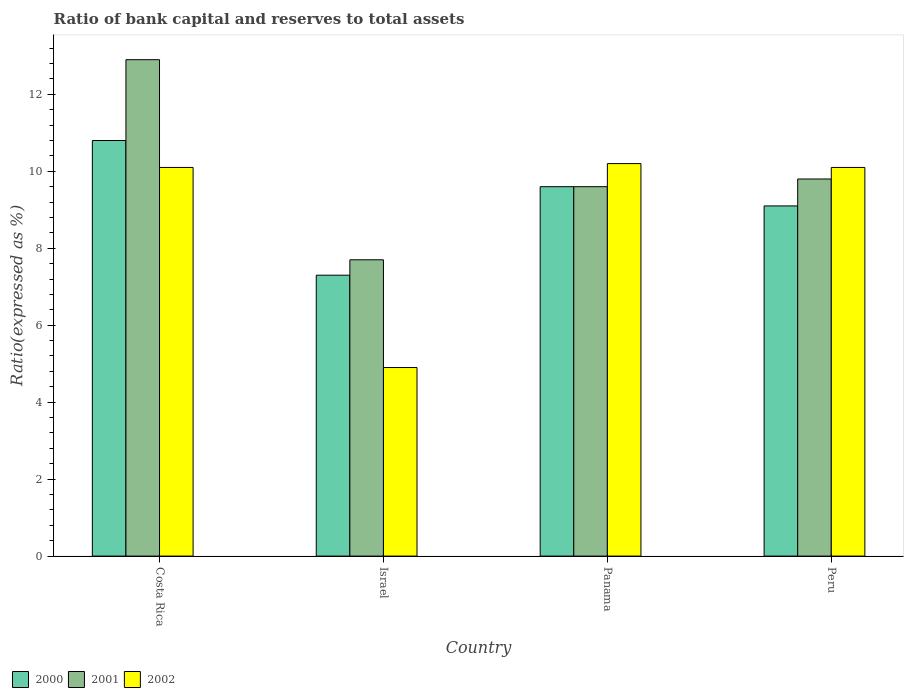What is the label of the 1st group of bars from the left?
Give a very brief answer. Costa Rica. In how many cases, is the number of bars for a given country not equal to the number of legend labels?
Provide a succinct answer. 0. In which country was the ratio of bank capital and reserves to total assets in 2000 minimum?
Provide a short and direct response. Israel. What is the total ratio of bank capital and reserves to total assets in 2000 in the graph?
Your answer should be very brief. 36.8. What is the difference between the ratio of bank capital and reserves to total assets in 2000 in Israel and that in Panama?
Your answer should be very brief. -2.3. What is the difference between the ratio of bank capital and reserves to total assets in 2002 in Peru and the ratio of bank capital and reserves to total assets in 2001 in Panama?
Provide a short and direct response. 0.5. What is the average ratio of bank capital and reserves to total assets in 2000 per country?
Offer a very short reply. 9.2. What is the difference between the ratio of bank capital and reserves to total assets of/in 2002 and ratio of bank capital and reserves to total assets of/in 2001 in Peru?
Keep it short and to the point. 0.3. In how many countries, is the ratio of bank capital and reserves to total assets in 2001 greater than 7.2 %?
Offer a very short reply. 4. What is the ratio of the ratio of bank capital and reserves to total assets in 2000 in Panama to that in Peru?
Provide a succinct answer. 1.05. Is the difference between the ratio of bank capital and reserves to total assets in 2002 in Israel and Panama greater than the difference between the ratio of bank capital and reserves to total assets in 2001 in Israel and Panama?
Keep it short and to the point. No. What is the difference between the highest and the second highest ratio of bank capital and reserves to total assets in 2001?
Give a very brief answer. -3.1. In how many countries, is the ratio of bank capital and reserves to total assets in 2000 greater than the average ratio of bank capital and reserves to total assets in 2000 taken over all countries?
Your answer should be very brief. 2. Is the sum of the ratio of bank capital and reserves to total assets in 2002 in Costa Rica and Israel greater than the maximum ratio of bank capital and reserves to total assets in 2001 across all countries?
Offer a very short reply. Yes. What does the 3rd bar from the left in Costa Rica represents?
Ensure brevity in your answer.  2002. Is it the case that in every country, the sum of the ratio of bank capital and reserves to total assets in 2002 and ratio of bank capital and reserves to total assets in 2000 is greater than the ratio of bank capital and reserves to total assets in 2001?
Make the answer very short. Yes. Are all the bars in the graph horizontal?
Your response must be concise. No. Are the values on the major ticks of Y-axis written in scientific E-notation?
Ensure brevity in your answer.  No. Does the graph contain grids?
Give a very brief answer. No. Where does the legend appear in the graph?
Give a very brief answer. Bottom left. How are the legend labels stacked?
Your response must be concise. Horizontal. What is the title of the graph?
Offer a terse response. Ratio of bank capital and reserves to total assets. Does "1990" appear as one of the legend labels in the graph?
Offer a terse response. No. What is the label or title of the Y-axis?
Provide a short and direct response. Ratio(expressed as %). What is the Ratio(expressed as %) in 2000 in Costa Rica?
Ensure brevity in your answer.  10.8. What is the Ratio(expressed as %) in 2002 in Costa Rica?
Offer a very short reply. 10.1. What is the Ratio(expressed as %) in 2000 in Panama?
Provide a succinct answer. 9.6. What is the Ratio(expressed as %) in 2002 in Panama?
Your response must be concise. 10.2. What is the Ratio(expressed as %) of 2000 in Peru?
Offer a very short reply. 9.1. Across all countries, what is the maximum Ratio(expressed as %) of 2001?
Your answer should be very brief. 12.9. What is the total Ratio(expressed as %) in 2000 in the graph?
Give a very brief answer. 36.8. What is the total Ratio(expressed as %) in 2001 in the graph?
Give a very brief answer. 40. What is the total Ratio(expressed as %) of 2002 in the graph?
Keep it short and to the point. 35.3. What is the difference between the Ratio(expressed as %) in 2000 in Costa Rica and that in Israel?
Your answer should be very brief. 3.5. What is the difference between the Ratio(expressed as %) in 2000 in Costa Rica and that in Panama?
Provide a succinct answer. 1.2. What is the difference between the Ratio(expressed as %) in 2001 in Costa Rica and that in Panama?
Provide a succinct answer. 3.3. What is the difference between the Ratio(expressed as %) in 2001 in Costa Rica and that in Peru?
Your response must be concise. 3.1. What is the difference between the Ratio(expressed as %) in 2002 in Costa Rica and that in Peru?
Your answer should be very brief. 0. What is the difference between the Ratio(expressed as %) in 2000 in Israel and that in Panama?
Make the answer very short. -2.3. What is the difference between the Ratio(expressed as %) in 2001 in Israel and that in Panama?
Your answer should be compact. -1.9. What is the difference between the Ratio(expressed as %) of 2001 in Israel and that in Peru?
Provide a succinct answer. -2.1. What is the difference between the Ratio(expressed as %) in 2002 in Israel and that in Peru?
Your answer should be very brief. -5.2. What is the difference between the Ratio(expressed as %) of 2000 in Panama and that in Peru?
Offer a very short reply. 0.5. What is the difference between the Ratio(expressed as %) of 2000 in Costa Rica and the Ratio(expressed as %) of 2001 in Israel?
Your response must be concise. 3.1. What is the difference between the Ratio(expressed as %) in 2000 in Costa Rica and the Ratio(expressed as %) in 2001 in Panama?
Give a very brief answer. 1.2. What is the difference between the Ratio(expressed as %) of 2000 in Costa Rica and the Ratio(expressed as %) of 2002 in Panama?
Your answer should be very brief. 0.6. What is the difference between the Ratio(expressed as %) in 2000 in Costa Rica and the Ratio(expressed as %) in 2001 in Peru?
Your answer should be very brief. 1. What is the difference between the Ratio(expressed as %) of 2001 in Israel and the Ratio(expressed as %) of 2002 in Panama?
Give a very brief answer. -2.5. What is the difference between the Ratio(expressed as %) of 2001 in Israel and the Ratio(expressed as %) of 2002 in Peru?
Ensure brevity in your answer.  -2.4. What is the difference between the Ratio(expressed as %) in 2001 in Panama and the Ratio(expressed as %) in 2002 in Peru?
Keep it short and to the point. -0.5. What is the average Ratio(expressed as %) of 2000 per country?
Give a very brief answer. 9.2. What is the average Ratio(expressed as %) of 2002 per country?
Your answer should be very brief. 8.82. What is the difference between the Ratio(expressed as %) of 2000 and Ratio(expressed as %) of 2001 in Costa Rica?
Your answer should be compact. -2.1. What is the difference between the Ratio(expressed as %) of 2001 and Ratio(expressed as %) of 2002 in Costa Rica?
Ensure brevity in your answer.  2.8. What is the difference between the Ratio(expressed as %) of 2000 and Ratio(expressed as %) of 2002 in Israel?
Offer a terse response. 2.4. What is the difference between the Ratio(expressed as %) of 2001 and Ratio(expressed as %) of 2002 in Israel?
Ensure brevity in your answer.  2.8. What is the difference between the Ratio(expressed as %) in 2000 and Ratio(expressed as %) in 2001 in Panama?
Your response must be concise. 0. What is the difference between the Ratio(expressed as %) in 2000 and Ratio(expressed as %) in 2002 in Panama?
Give a very brief answer. -0.6. What is the difference between the Ratio(expressed as %) in 2001 and Ratio(expressed as %) in 2002 in Panama?
Keep it short and to the point. -0.6. What is the ratio of the Ratio(expressed as %) of 2000 in Costa Rica to that in Israel?
Your answer should be very brief. 1.48. What is the ratio of the Ratio(expressed as %) of 2001 in Costa Rica to that in Israel?
Keep it short and to the point. 1.68. What is the ratio of the Ratio(expressed as %) of 2002 in Costa Rica to that in Israel?
Keep it short and to the point. 2.06. What is the ratio of the Ratio(expressed as %) of 2000 in Costa Rica to that in Panama?
Your answer should be very brief. 1.12. What is the ratio of the Ratio(expressed as %) of 2001 in Costa Rica to that in Panama?
Offer a terse response. 1.34. What is the ratio of the Ratio(expressed as %) of 2002 in Costa Rica to that in Panama?
Ensure brevity in your answer.  0.99. What is the ratio of the Ratio(expressed as %) of 2000 in Costa Rica to that in Peru?
Keep it short and to the point. 1.19. What is the ratio of the Ratio(expressed as %) in 2001 in Costa Rica to that in Peru?
Your response must be concise. 1.32. What is the ratio of the Ratio(expressed as %) in 2000 in Israel to that in Panama?
Ensure brevity in your answer.  0.76. What is the ratio of the Ratio(expressed as %) in 2001 in Israel to that in Panama?
Your response must be concise. 0.8. What is the ratio of the Ratio(expressed as %) of 2002 in Israel to that in Panama?
Your answer should be compact. 0.48. What is the ratio of the Ratio(expressed as %) in 2000 in Israel to that in Peru?
Provide a succinct answer. 0.8. What is the ratio of the Ratio(expressed as %) in 2001 in Israel to that in Peru?
Keep it short and to the point. 0.79. What is the ratio of the Ratio(expressed as %) in 2002 in Israel to that in Peru?
Give a very brief answer. 0.49. What is the ratio of the Ratio(expressed as %) of 2000 in Panama to that in Peru?
Give a very brief answer. 1.05. What is the ratio of the Ratio(expressed as %) in 2001 in Panama to that in Peru?
Keep it short and to the point. 0.98. What is the ratio of the Ratio(expressed as %) in 2002 in Panama to that in Peru?
Provide a succinct answer. 1.01. What is the difference between the highest and the second highest Ratio(expressed as %) of 2000?
Keep it short and to the point. 1.2. What is the difference between the highest and the second highest Ratio(expressed as %) of 2001?
Offer a terse response. 3.1. What is the difference between the highest and the lowest Ratio(expressed as %) in 2002?
Make the answer very short. 5.3. 